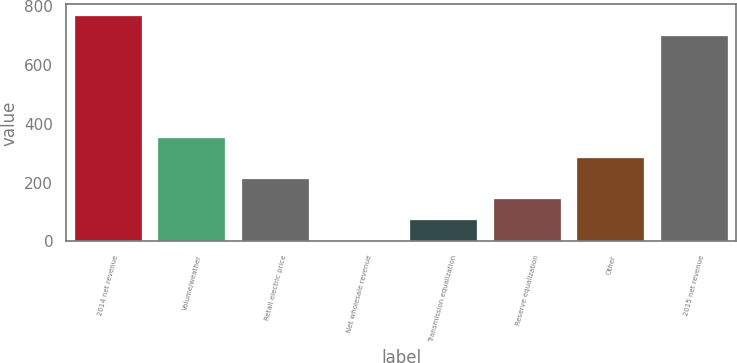<chart> <loc_0><loc_0><loc_500><loc_500><bar_chart><fcel>2014 net revenue<fcel>Volume/weather<fcel>Retail electric price<fcel>Net wholesale revenue<fcel>Transmission equalization<fcel>Reserve equalization<fcel>Other<fcel>2015 net revenue<nl><fcel>766.15<fcel>351.95<fcel>212.25<fcel>2.7<fcel>72.55<fcel>142.4<fcel>282.1<fcel>696.3<nl></chart> 